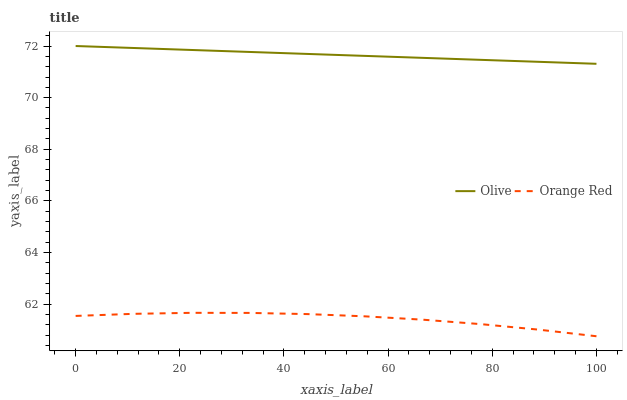Does Orange Red have the minimum area under the curve?
Answer yes or no. Yes. Does Olive have the maximum area under the curve?
Answer yes or no. Yes. Does Orange Red have the maximum area under the curve?
Answer yes or no. No. Is Olive the smoothest?
Answer yes or no. Yes. Is Orange Red the roughest?
Answer yes or no. Yes. Is Orange Red the smoothest?
Answer yes or no. No. Does Orange Red have the lowest value?
Answer yes or no. Yes. Does Olive have the highest value?
Answer yes or no. Yes. Does Orange Red have the highest value?
Answer yes or no. No. Is Orange Red less than Olive?
Answer yes or no. Yes. Is Olive greater than Orange Red?
Answer yes or no. Yes. Does Orange Red intersect Olive?
Answer yes or no. No. 